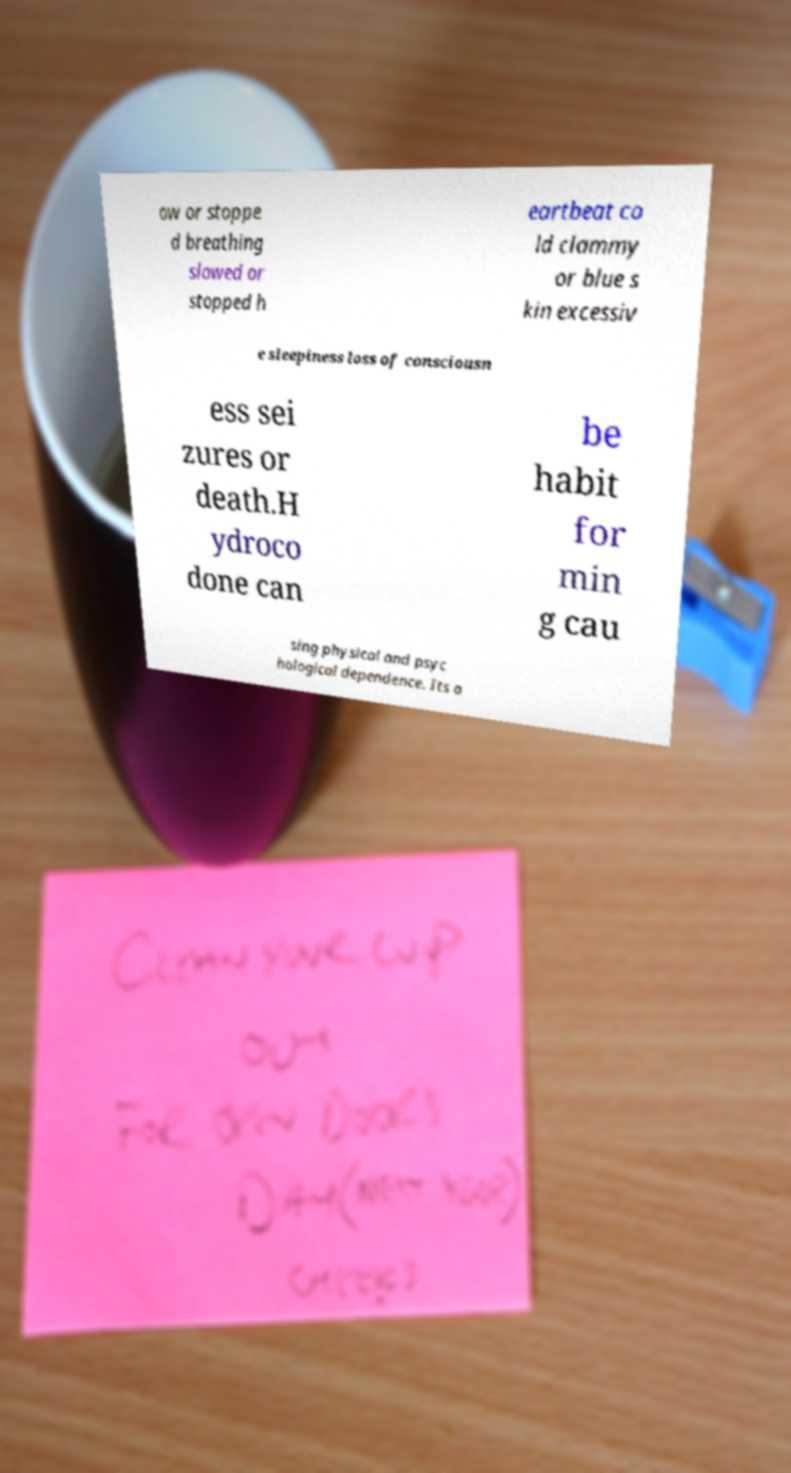For documentation purposes, I need the text within this image transcribed. Could you provide that? ow or stoppe d breathing slowed or stopped h eartbeat co ld clammy or blue s kin excessiv e sleepiness loss of consciousn ess sei zures or death.H ydroco done can be habit for min g cau sing physical and psyc hological dependence. Its a 